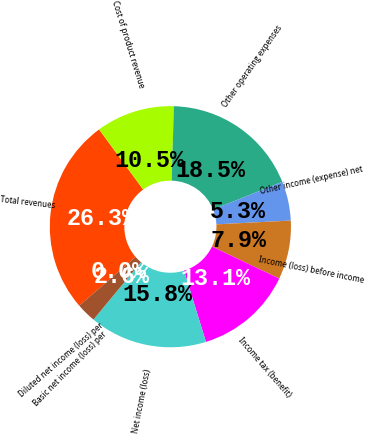Convert chart. <chart><loc_0><loc_0><loc_500><loc_500><pie_chart><fcel>Total revenues<fcel>Cost of product revenue<fcel>Other operating expenses<fcel>Other income (expense) net<fcel>Income (loss) before income<fcel>Income tax (benefit)<fcel>Net income (loss)<fcel>Basic net income (loss) per<fcel>Diluted net income (loss) per<nl><fcel>26.3%<fcel>10.52%<fcel>18.47%<fcel>5.26%<fcel>7.89%<fcel>13.15%<fcel>15.78%<fcel>2.63%<fcel>0.0%<nl></chart> 